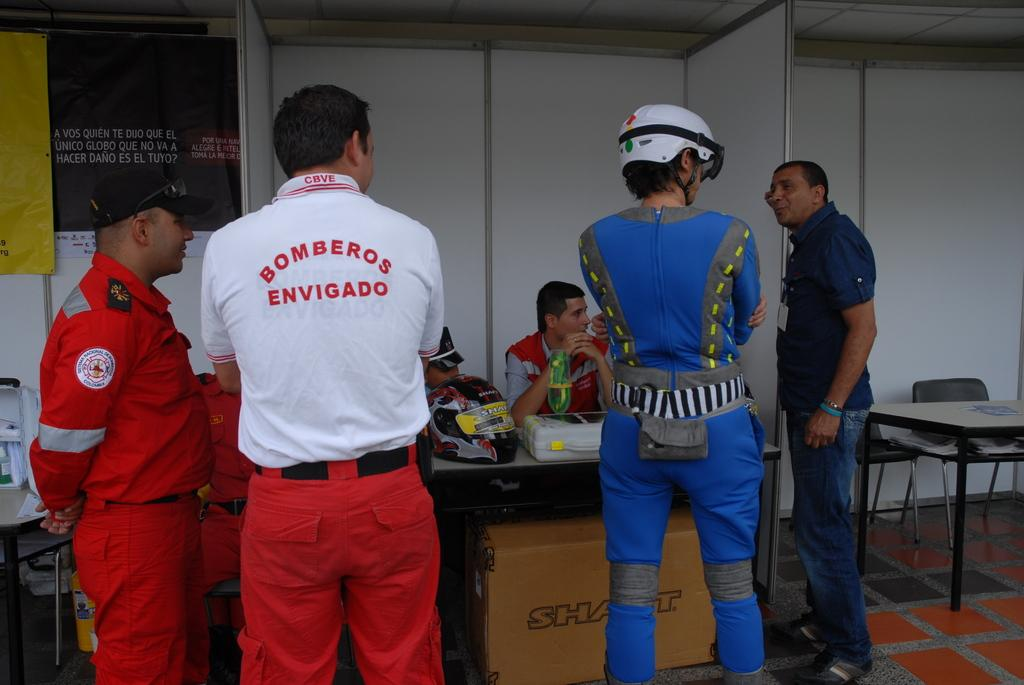<image>
Give a short and clear explanation of the subsequent image. A group of people and one is wearing a bomberos shirt 